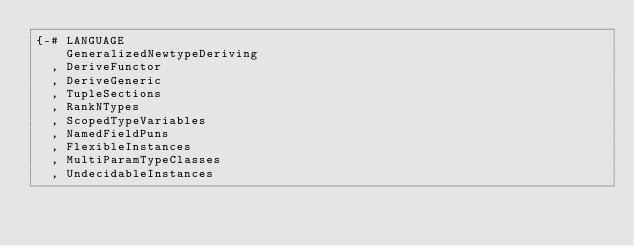Convert code to text. <code><loc_0><loc_0><loc_500><loc_500><_Haskell_>{-# LANGUAGE
    GeneralizedNewtypeDeriving
  , DeriveFunctor
  , DeriveGeneric
  , TupleSections
  , RankNTypes
  , ScopedTypeVariables
  , NamedFieldPuns
  , FlexibleInstances
  , MultiParamTypeClasses
  , UndecidableInstances</code> 